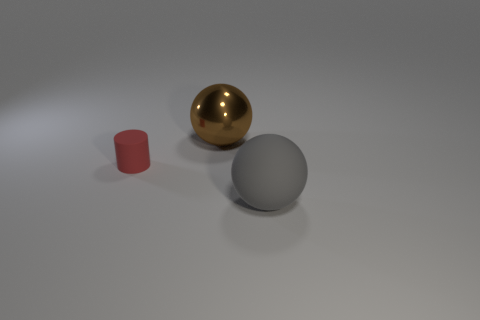Add 2 tiny rubber cylinders. How many objects exist? 5 Subtract all brown spheres. How many spheres are left? 1 Subtract all red cubes. How many cyan cylinders are left? 0 Add 1 balls. How many balls exist? 3 Subtract 0 cyan cylinders. How many objects are left? 3 Subtract all cylinders. How many objects are left? 2 Subtract 1 cylinders. How many cylinders are left? 0 Subtract all yellow cylinders. Subtract all gray spheres. How many cylinders are left? 1 Subtract all big purple metallic objects. Subtract all small rubber cylinders. How many objects are left? 2 Add 3 small red cylinders. How many small red cylinders are left? 4 